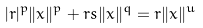<formula> <loc_0><loc_0><loc_500><loc_500>| r | ^ { p } \| x \| ^ { p } + r s \| x \| ^ { q } = r \| x \| ^ { u }</formula> 